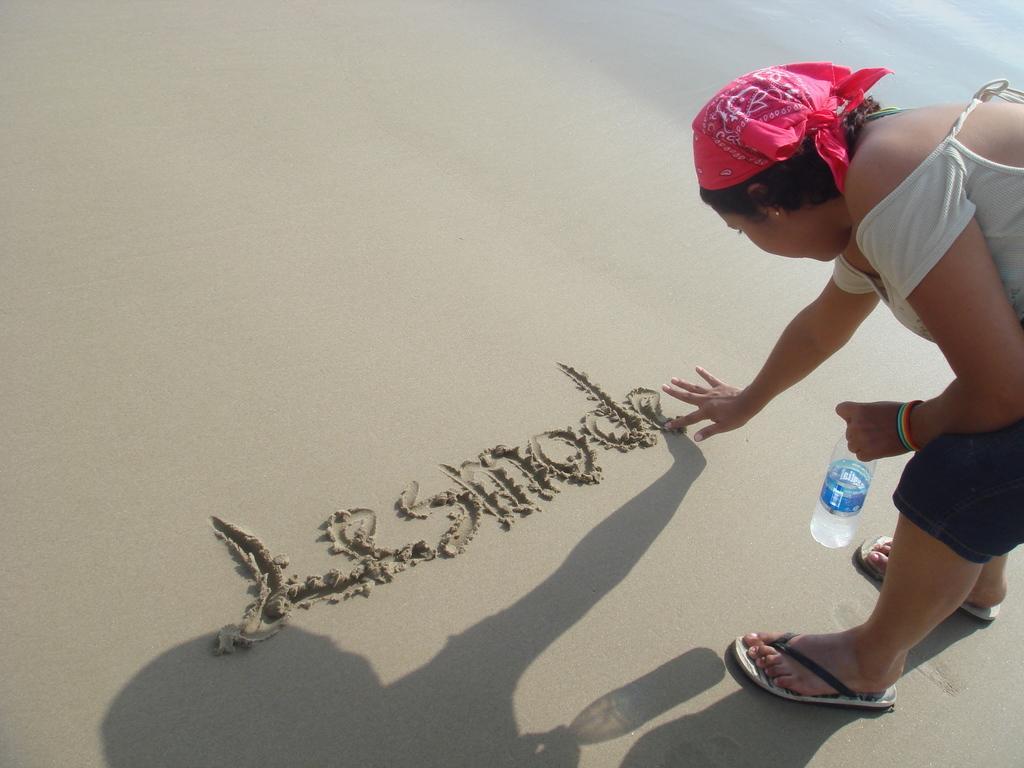Could you give a brief overview of what you see in this image? The woman on the right corner of the picture, wearing white t-shirt who is wearing pink color cloth on her head is writing something on the sand. She is even holding water bottle in her hand. Beside her, we see water and this water might be at sea. This picture might be clicked at the seashore. 